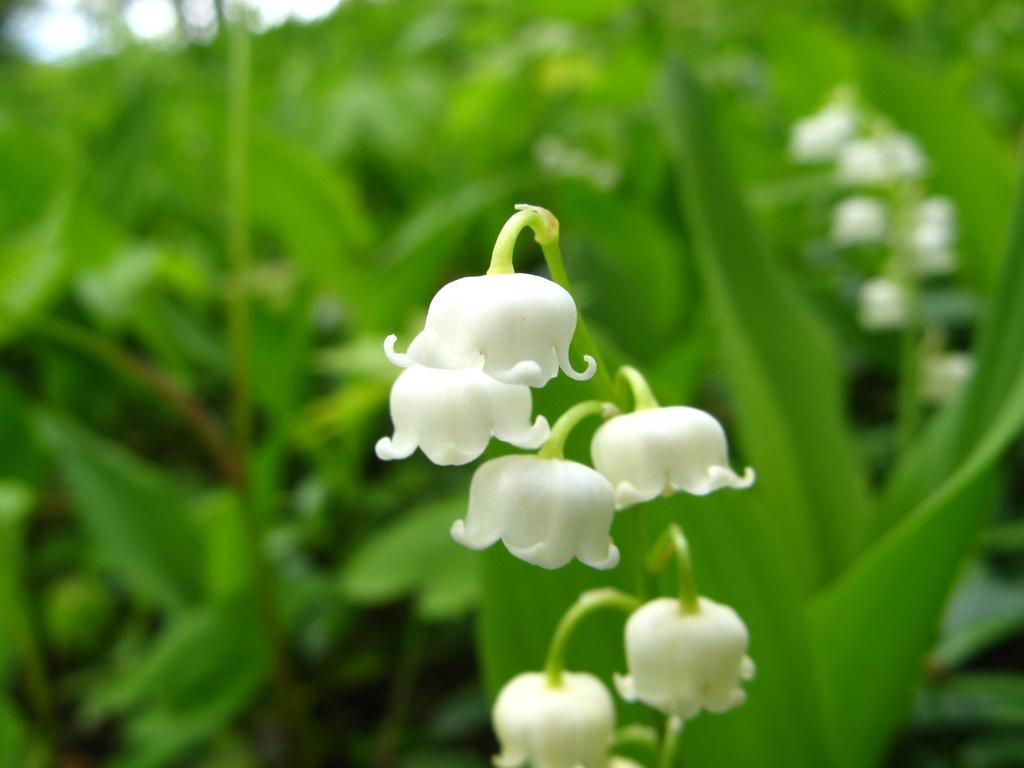What type of living organisms can be seen in the image? There are flowers in the image. Can you describe the background of the image? The background of the image is blurred. What type of music can be heard playing in the background of the image? There is no music present in the image, as it only features flowers and a blurred background. 